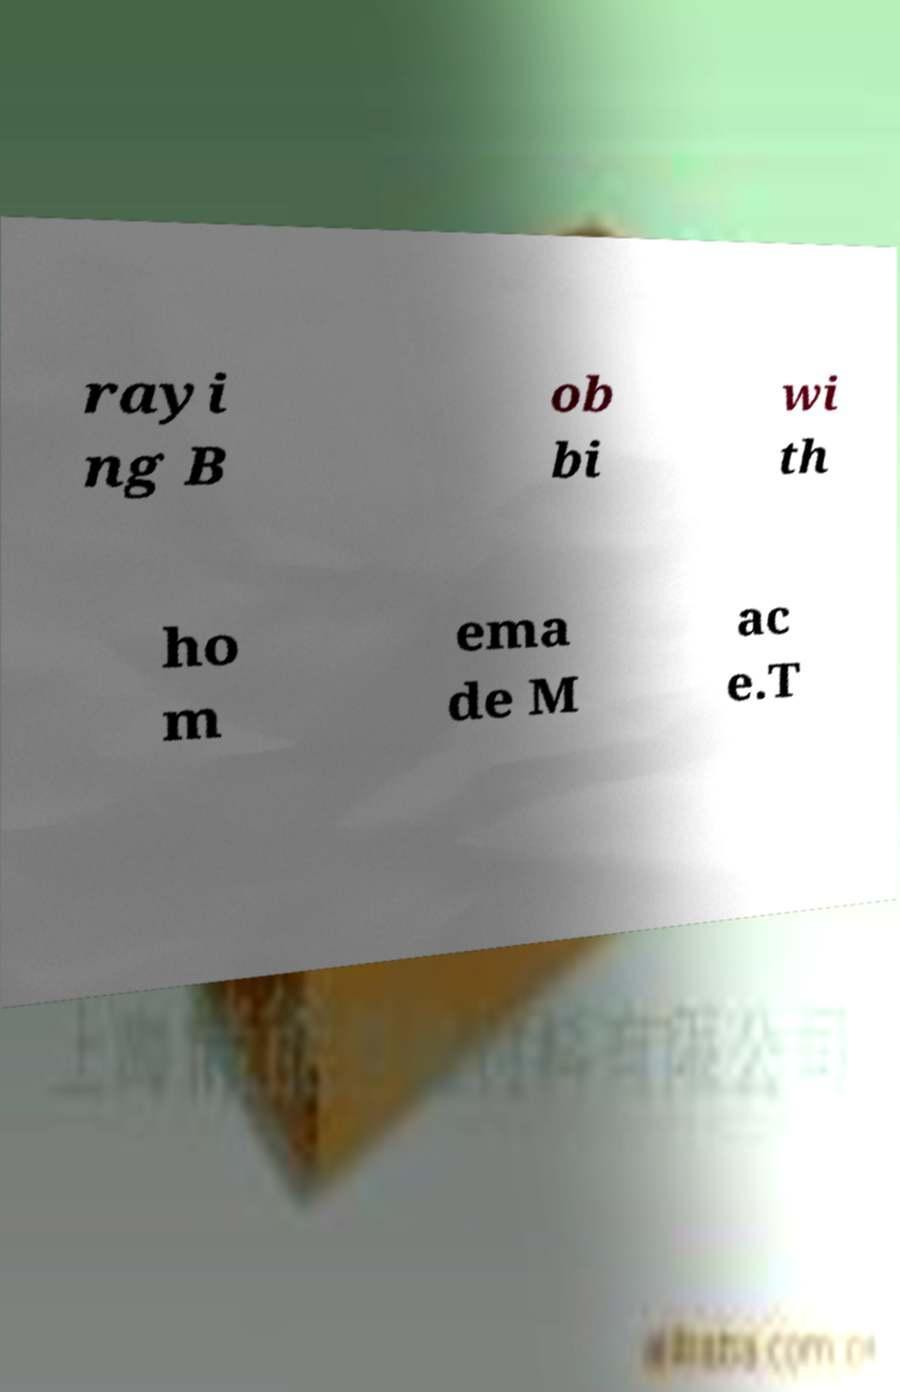Can you read and provide the text displayed in the image?This photo seems to have some interesting text. Can you extract and type it out for me? rayi ng B ob bi wi th ho m ema de M ac e.T 